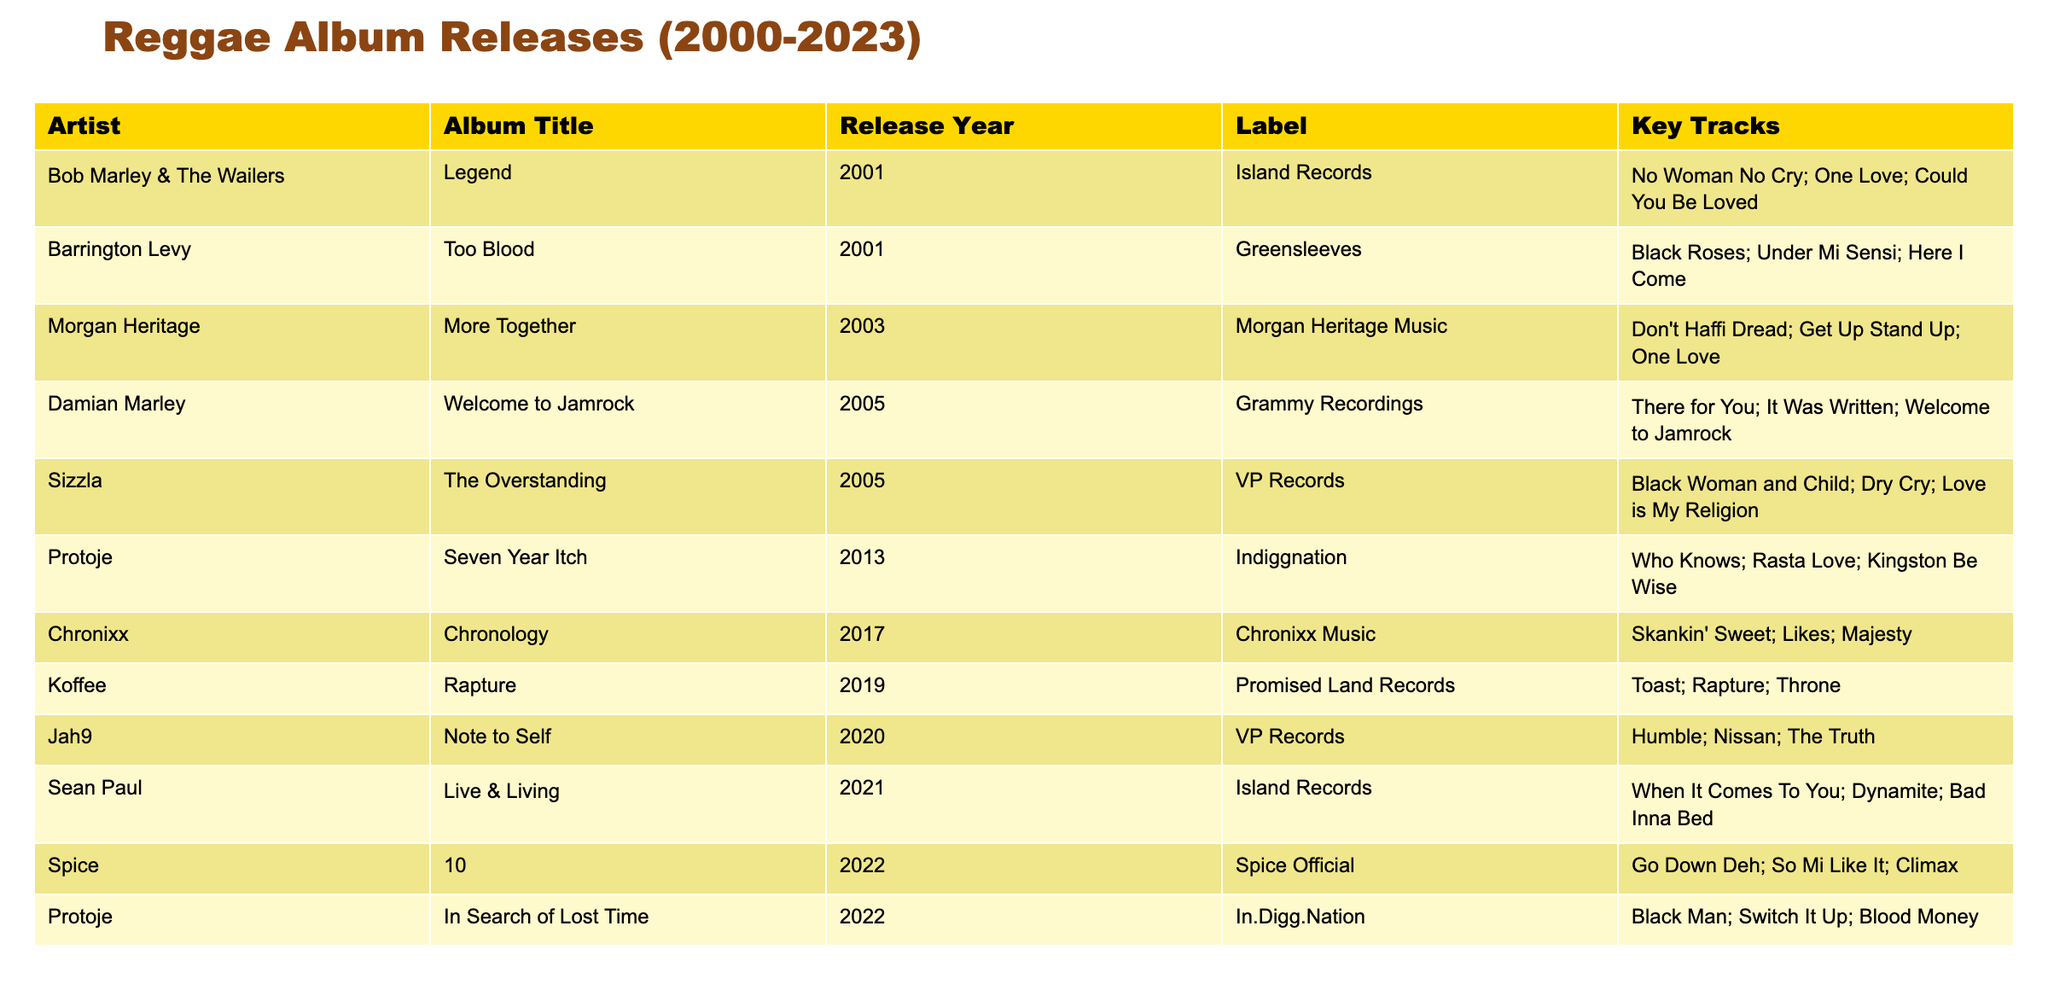What was the release year of Barrington Levy's album? Barrington Levy released the album "Too Blood" in 2001, as indicated in the table under the "Release Year" column.
Answer: 2001 Which artist released the album "Rapture"? The table shows that Koffee released the album "Rapture" in 2019, as listed under the "Artist" and "Album Title" columns.
Answer: Koffee How many albums are listed from 2005? The table contains two albums released in 2005: Damian Marley’s "Welcome to Jamrock" and Sizzla's "The Overstanding." Thus, the total count is 2.
Answer: 2 Did Protoje release any albums in 2022? Yes, the table indicates that Protoje released two albums in 2022: "In Search of Lost Time" and another earlier album "Seven Year Itch" released in 2013. However, only the one released in 2022 is considered for this question.
Answer: Yes Which album released between 2013 and 2017 had "Skankin' Sweet" as a key track? From the table, "Chronology" by Chronixx was released in 2017, featuring "Skankin' Sweet" among its key tracks.
Answer: Chronology What is the total number of albums listed for the year 2022? The table lists two albums released in 2022: Spice's "10" and Protoje's "In Search of Lost Time." Therefore, the count is 2.
Answer: 2 Is "One Love" a key track for any album in the table? Yes, "One Love" is a key track in the album "Legend" by Bob Marley & The Wailers, according to the information in the table.
Answer: Yes What is the count of albums released by Morgan Heritage? The data shows that Morgan Heritage released one album, "More Together," in 2003. Hence, the total count is 1.
Answer: 1 Which artist has the most recent album listed, and what is its title? The most recent album listed is "10" by Spice, released in 2022, which can be identified by checking the "Release Year" column for the latest year.
Answer: Spice, 10 